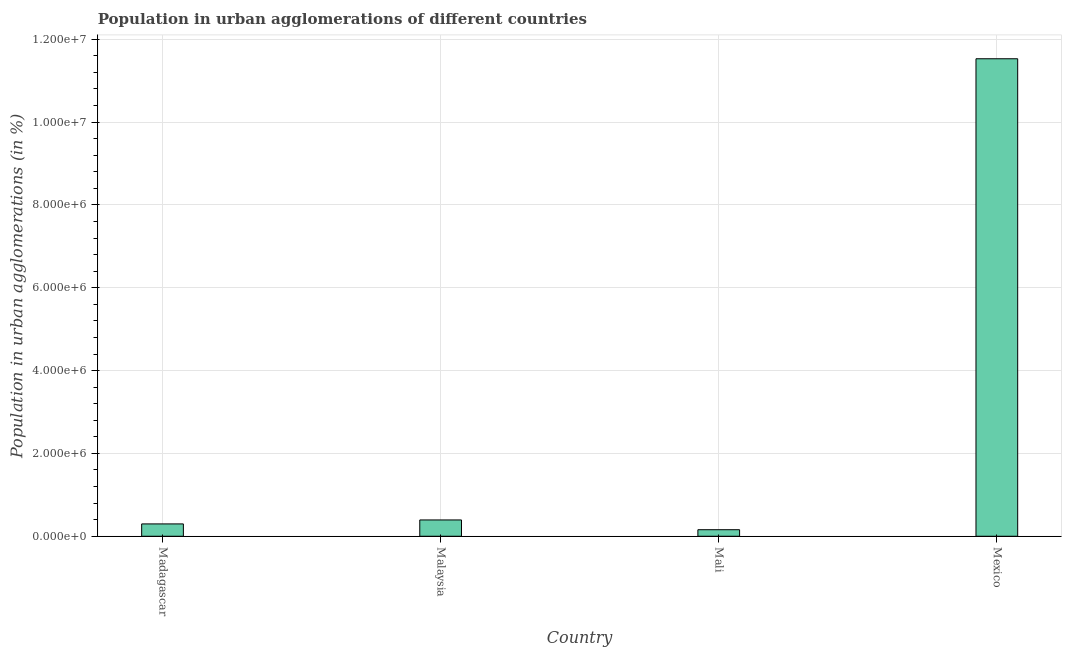Does the graph contain any zero values?
Make the answer very short. No. What is the title of the graph?
Keep it short and to the point. Population in urban agglomerations of different countries. What is the label or title of the X-axis?
Your response must be concise. Country. What is the label or title of the Y-axis?
Ensure brevity in your answer.  Population in urban agglomerations (in %). What is the population in urban agglomerations in Mali?
Offer a terse response. 1.58e+05. Across all countries, what is the maximum population in urban agglomerations?
Your answer should be very brief. 1.15e+07. Across all countries, what is the minimum population in urban agglomerations?
Your response must be concise. 1.58e+05. In which country was the population in urban agglomerations maximum?
Provide a short and direct response. Mexico. In which country was the population in urban agglomerations minimum?
Ensure brevity in your answer.  Mali. What is the sum of the population in urban agglomerations?
Offer a very short reply. 1.24e+07. What is the difference between the population in urban agglomerations in Madagascar and Malaysia?
Provide a succinct answer. -9.57e+04. What is the average population in urban agglomerations per country?
Provide a succinct answer. 3.09e+06. What is the median population in urban agglomerations?
Keep it short and to the point. 3.46e+05. In how many countries, is the population in urban agglomerations greater than 9600000 %?
Make the answer very short. 1. What is the ratio of the population in urban agglomerations in Madagascar to that in Mali?
Offer a terse response. 1.89. Is the population in urban agglomerations in Mali less than that in Mexico?
Keep it short and to the point. Yes. Is the difference between the population in urban agglomerations in Madagascar and Mali greater than the difference between any two countries?
Give a very brief answer. No. What is the difference between the highest and the second highest population in urban agglomerations?
Offer a very short reply. 1.11e+07. Is the sum of the population in urban agglomerations in Malaysia and Mexico greater than the maximum population in urban agglomerations across all countries?
Your response must be concise. Yes. What is the difference between the highest and the lowest population in urban agglomerations?
Make the answer very short. 1.14e+07. Are all the bars in the graph horizontal?
Your answer should be very brief. No. Are the values on the major ticks of Y-axis written in scientific E-notation?
Offer a very short reply. Yes. What is the Population in urban agglomerations (in %) of Madagascar?
Your response must be concise. 2.98e+05. What is the Population in urban agglomerations (in %) of Malaysia?
Your answer should be very brief. 3.94e+05. What is the Population in urban agglomerations (in %) of Mali?
Offer a very short reply. 1.58e+05. What is the Population in urban agglomerations (in %) in Mexico?
Provide a succinct answer. 1.15e+07. What is the difference between the Population in urban agglomerations (in %) in Madagascar and Malaysia?
Offer a very short reply. -9.57e+04. What is the difference between the Population in urban agglomerations (in %) in Madagascar and Mali?
Give a very brief answer. 1.40e+05. What is the difference between the Population in urban agglomerations (in %) in Madagascar and Mexico?
Offer a very short reply. -1.12e+07. What is the difference between the Population in urban agglomerations (in %) in Malaysia and Mali?
Make the answer very short. 2.36e+05. What is the difference between the Population in urban agglomerations (in %) in Malaysia and Mexico?
Offer a very short reply. -1.11e+07. What is the difference between the Population in urban agglomerations (in %) in Mali and Mexico?
Provide a short and direct response. -1.14e+07. What is the ratio of the Population in urban agglomerations (in %) in Madagascar to that in Malaysia?
Ensure brevity in your answer.  0.76. What is the ratio of the Population in urban agglomerations (in %) in Madagascar to that in Mali?
Give a very brief answer. 1.89. What is the ratio of the Population in urban agglomerations (in %) in Madagascar to that in Mexico?
Keep it short and to the point. 0.03. What is the ratio of the Population in urban agglomerations (in %) in Malaysia to that in Mali?
Your answer should be very brief. 2.49. What is the ratio of the Population in urban agglomerations (in %) in Malaysia to that in Mexico?
Provide a succinct answer. 0.03. What is the ratio of the Population in urban agglomerations (in %) in Mali to that in Mexico?
Give a very brief answer. 0.01. 